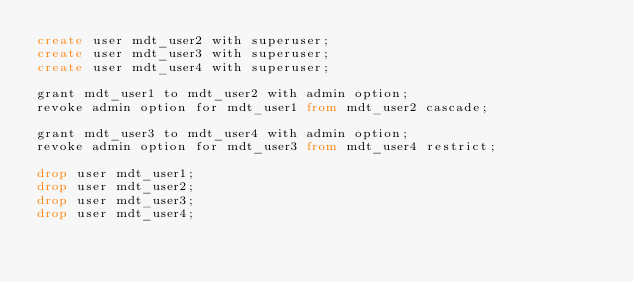Convert code to text. <code><loc_0><loc_0><loc_500><loc_500><_SQL_>create user mdt_user2 with superuser;
create user mdt_user3 with superuser;
create user mdt_user4 with superuser;

grant mdt_user1 to mdt_user2 with admin option;
revoke admin option for mdt_user1 from mdt_user2 cascade;

grant mdt_user3 to mdt_user4 with admin option;
revoke admin option for mdt_user3 from mdt_user4 restrict;

drop user mdt_user1;
drop user mdt_user2;
drop user mdt_user3;
drop user mdt_user4;

</code> 